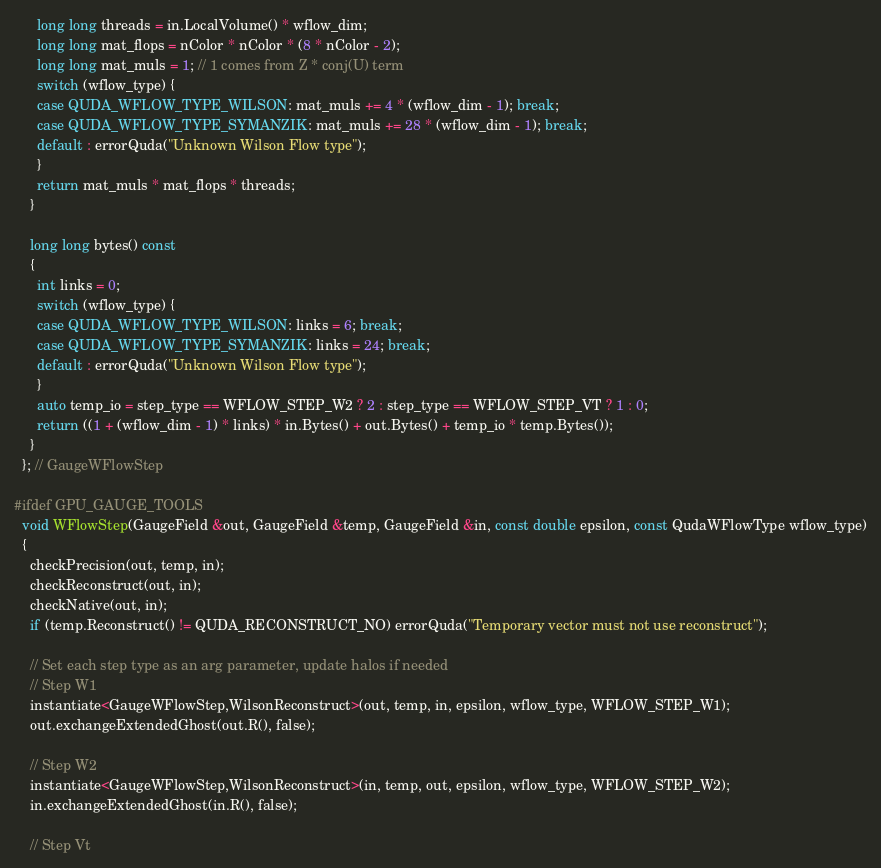<code> <loc_0><loc_0><loc_500><loc_500><_Cuda_>      long long threads = in.LocalVolume() * wflow_dim;
      long long mat_flops = nColor * nColor * (8 * nColor - 2);
      long long mat_muls = 1; // 1 comes from Z * conj(U) term
      switch (wflow_type) {
      case QUDA_WFLOW_TYPE_WILSON: mat_muls += 4 * (wflow_dim - 1); break;
      case QUDA_WFLOW_TYPE_SYMANZIK: mat_muls += 28 * (wflow_dim - 1); break;
      default : errorQuda("Unknown Wilson Flow type");
      }
      return mat_muls * mat_flops * threads;
    }

    long long bytes() const
    {
      int links = 0;
      switch (wflow_type) {
      case QUDA_WFLOW_TYPE_WILSON: links = 6; break;
      case QUDA_WFLOW_TYPE_SYMANZIK: links = 24; break;
      default : errorQuda("Unknown Wilson Flow type");
      }
      auto temp_io = step_type == WFLOW_STEP_W2 ? 2 : step_type == WFLOW_STEP_VT ? 1 : 0;
      return ((1 + (wflow_dim - 1) * links) * in.Bytes() + out.Bytes() + temp_io * temp.Bytes());
    }
  }; // GaugeWFlowStep

#ifdef GPU_GAUGE_TOOLS
  void WFlowStep(GaugeField &out, GaugeField &temp, GaugeField &in, const double epsilon, const QudaWFlowType wflow_type)
  {
    checkPrecision(out, temp, in);
    checkReconstruct(out, in);
    checkNative(out, in);
    if (temp.Reconstruct() != QUDA_RECONSTRUCT_NO) errorQuda("Temporary vector must not use reconstruct");

    // Set each step type as an arg parameter, update halos if needed
    // Step W1
    instantiate<GaugeWFlowStep,WilsonReconstruct>(out, temp, in, epsilon, wflow_type, WFLOW_STEP_W1);
    out.exchangeExtendedGhost(out.R(), false);

    // Step W2
    instantiate<GaugeWFlowStep,WilsonReconstruct>(in, temp, out, epsilon, wflow_type, WFLOW_STEP_W2);
    in.exchangeExtendedGhost(in.R(), false);

    // Step Vt</code> 